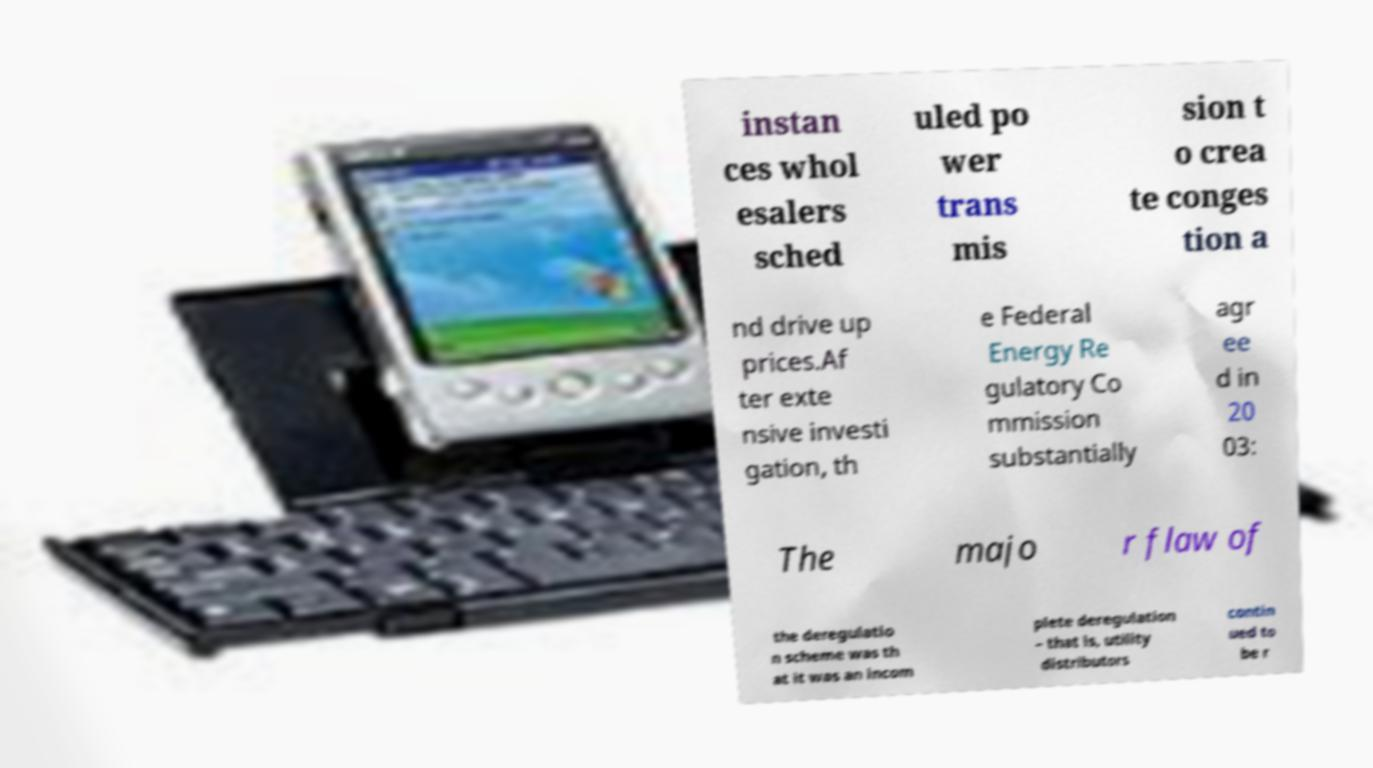Can you accurately transcribe the text from the provided image for me? instan ces whol esalers sched uled po wer trans mis sion t o crea te conges tion a nd drive up prices.Af ter exte nsive investi gation, th e Federal Energy Re gulatory Co mmission substantially agr ee d in 20 03: The majo r flaw of the deregulatio n scheme was th at it was an incom plete deregulation – that is, utility distributors contin ued to be r 